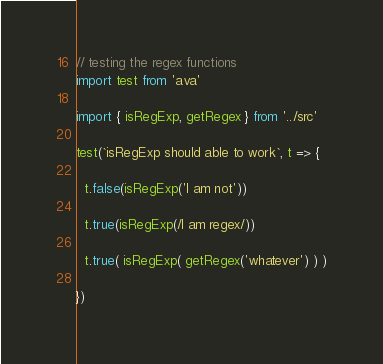Convert code to text. <code><loc_0><loc_0><loc_500><loc_500><_TypeScript_>// testing the regex functions
import test from 'ava'

import { isRegExp, getRegex } from '../src'

test(`isRegExp should able to work`, t => {

  t.false(isRegExp('I am not'))

  t.true(isRegExp(/I am regex/))

  t.true( isRegExp( getRegex('whatever') ) )

})
</code> 